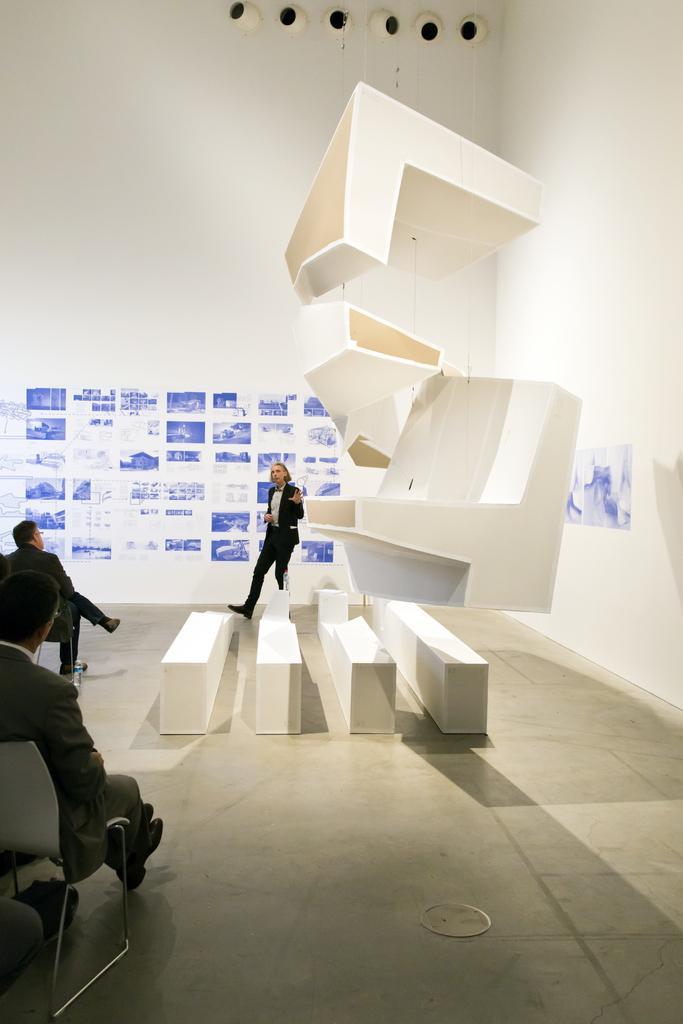Describe this image in one or two sentences. In this picture we can see few people are sitting on the chairs, side we can see architecture one person is standing and talking. 